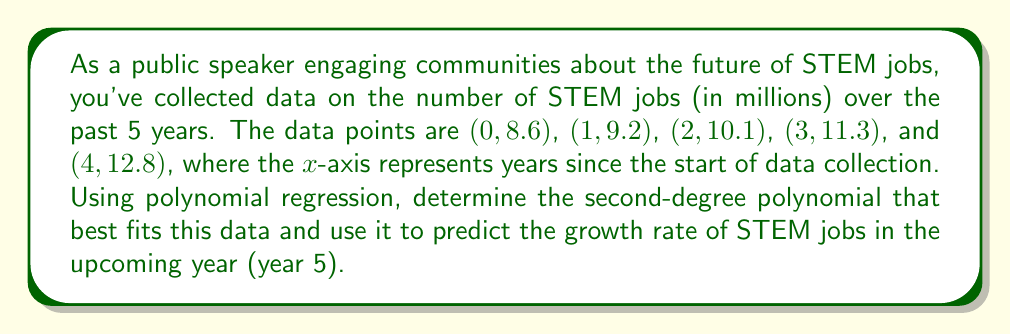Help me with this question. To solve this problem, we'll use polynomial regression to find the best-fitting second-degree polynomial, then calculate the growth rate.

Step 1: Set up the polynomial regression equation
Let the polynomial be of the form: $y = ax^2 + bx + c$

Step 2: Create a system of normal equations
For a second-degree polynomial, we need three equations:
$$\sum y = an\sum x^2 + b\sum x + nc$$
$$\sum xy = a\sum x^3 + b\sum x^2 + c\sum x$$
$$\sum x^2y = a\sum x^4 + b\sum x^3 + c\sum x^2$$

Step 3: Calculate the sums
$\sum x = 0 + 1 + 2 + 3 + 4 = 10$
$\sum x^2 = 0 + 1 + 4 + 9 + 16 = 30$
$\sum x^3 = 0 + 1 + 8 + 27 + 64 = 100$
$\sum x^4 = 0 + 1 + 16 + 81 + 256 = 354$
$\sum y = 8.6 + 9.2 + 10.1 + 11.3 + 12.8 = 52$
$\sum xy = 0(8.6) + 1(9.2) + 2(10.1) + 3(11.3) + 4(12.8) = 132.4$
$\sum x^2y = 0(8.6) + 1(9.2) + 4(10.1) + 9(11.3) + 16(12.8) = 430.8$

Step 4: Substitute into the normal equations
$$52 = 30a + 10b + 5c$$
$$132.4 = 100a + 30b + 10c$$
$$430.8 = 354a + 100b + 30c$$

Step 5: Solve the system of equations
Using a matrix solver or elimination method, we get:
$a \approx 0.125$, $b \approx 0.91$, $c \approx 8.54$

So, the polynomial is: $y \approx 0.125x^2 + 0.91x + 8.54$

Step 6: Calculate the growth rate for year 5
The growth rate is the derivative of the polynomial at x = 5:
$$\frac{dy}{dx} = 0.25x + 0.91$$
At x = 5: $\frac{dy}{dx} = 0.25(5) + 0.91 = 2.16$

This means the growth rate at year 5 is approximately 2.16 million STEM jobs per year.
Answer: 2.16 million jobs/year 